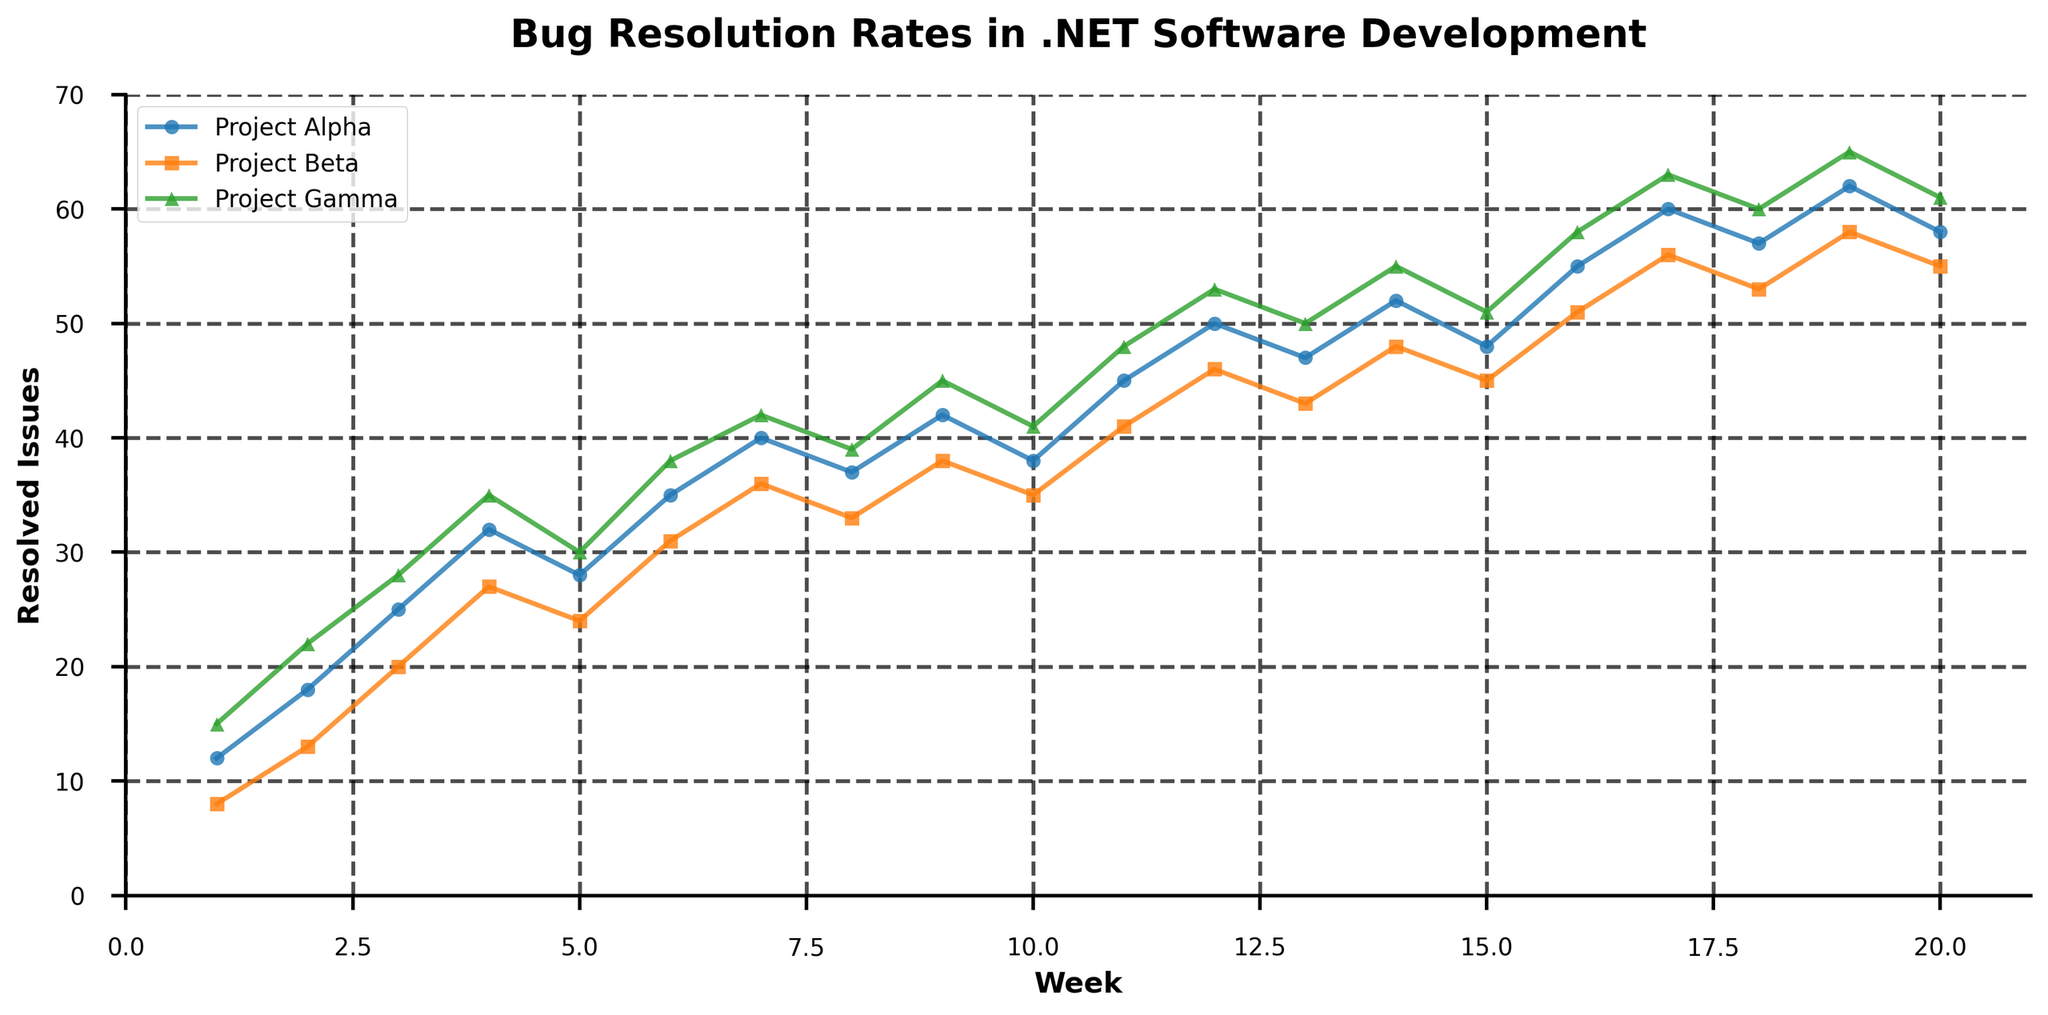What is the highest number of resolved issues for Project Alpha? The highest number of resolved issues for Project Alpha can be identified by looking for the peak value on the line associated with Project Alpha. The line peaks at Week 19 with 62 resolved issues.
Answer: 62 Which project had the most consistent bug resolution rate throughout the project lifecycle? To determine which project had the most consistent bug resolution rate, observe the smoothness of each line. The line with the fewest fluctuations is the most consistent. Project Beta's line appears the most consistent with fewer sharp changes compared to Project Alpha and Project Gamma.
Answer: Project Beta At which week did Project Gamma surpass 50 resolved issues? To determine the week Project Gamma surpassed 50 resolved issues, find the week where the line representing Project Gamma crosses the 50 resolved issues mark. This occurs in Week 12.
Answer: Week 12 How many weeks did Project Beta maintain more than 40 resolved issues? To find the number of weeks Project Beta maintained more than 40 resolved issues, count the weeks where the line representing Project Beta stays above 40 resolved issues. This occurs from Week 11 to Week 20, totaling 10 weeks.
Answer: 10 weeks What is the difference in resolved issues between Project Alpha and Project Gamma at Week 10? Find the number of resolved issues for both projects at Week 10 and subtract the lesser value from the greater value. Project Alpha has 38 resolved issues while Project Gamma has 41. The difference is 41 - 38 = 3.
Answer: 3 Which project had the highest increase in resolved issues from Week 1 to Week 12? To determine which project had the highest increase, calculate the difference in resolved issues from Week 1 to Week 12 for each project. Project Alpha increased from 12 to 50 (38), Project Beta from 8 to 46 (38), and Project Gamma from 15 to 53 (38). All projects had the same increase of 38.
Answer: All projects How did the number of resolved issues for Project Alpha change from Week 8 to Week 9? To find the change in resolved issues for Project Alpha between Week 8 and Week 9, subtract the value at Week 8 from the value at Week 9. The resolved issues changed from 37 to 42. The change is 42 - 37 = 5.
Answer: 5 In which week did all projects have the highest combined total of resolved issues? Sum the resolved issues for all three projects week by week and find the week with the highest total. The highest combined total is at Week 17 with 60 (Alpha) + 56 (Beta) + 63 (Gamma) = 179.
Answer: Week 17 What is the average number of resolved issues for Project Beta over the first 10 weeks? Sum the resolved issues for Project Beta from Week 1 to Week 10 and divide by 10. The total from Weeks 1-10 is 324, so the average is 324/10 = 32.4.
Answer: 32.4 